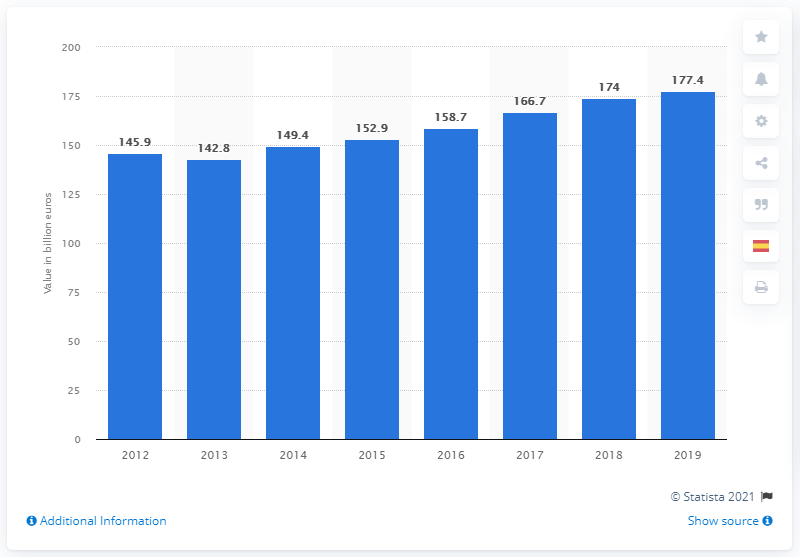Does this chart provide any data on the sectors contributing to Spain's GDP? The chart doesn't specify the sectors contributing to Spain's GDP; it only displays the total value for each year. To analyze sector-specific contributions, we would need a more detailed breakdown or different datasets. 